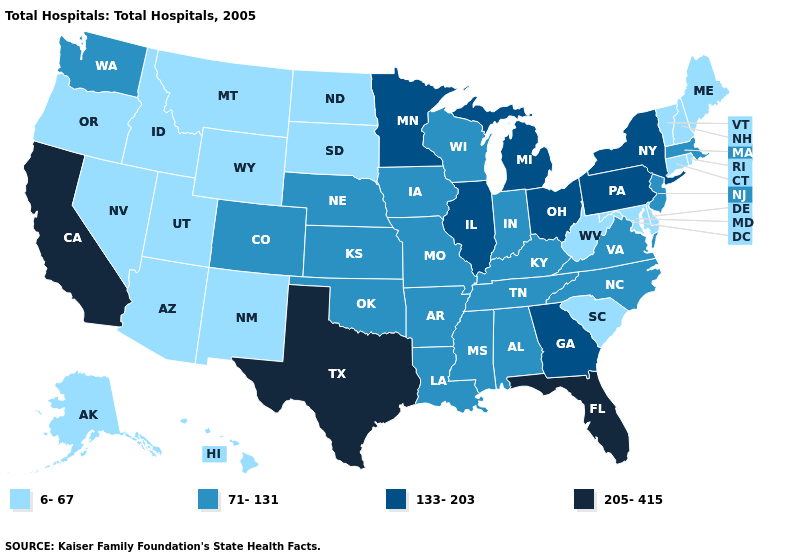Does Massachusetts have the lowest value in the USA?
Short answer required. No. Does Maryland have the lowest value in the USA?
Give a very brief answer. Yes. What is the lowest value in states that border Massachusetts?
Answer briefly. 6-67. Among the states that border Delaware , which have the highest value?
Give a very brief answer. Pennsylvania. Does Maryland have the same value as California?
Give a very brief answer. No. Name the states that have a value in the range 133-203?
Concise answer only. Georgia, Illinois, Michigan, Minnesota, New York, Ohio, Pennsylvania. What is the lowest value in the USA?
Quick response, please. 6-67. Name the states that have a value in the range 133-203?
Concise answer only. Georgia, Illinois, Michigan, Minnesota, New York, Ohio, Pennsylvania. Which states have the lowest value in the MidWest?
Keep it brief. North Dakota, South Dakota. Which states have the highest value in the USA?
Keep it brief. California, Florida, Texas. Does South Carolina have the lowest value in the USA?
Answer briefly. Yes. Name the states that have a value in the range 71-131?
Short answer required. Alabama, Arkansas, Colorado, Indiana, Iowa, Kansas, Kentucky, Louisiana, Massachusetts, Mississippi, Missouri, Nebraska, New Jersey, North Carolina, Oklahoma, Tennessee, Virginia, Washington, Wisconsin. Among the states that border Utah , does Colorado have the highest value?
Keep it brief. Yes. Among the states that border Florida , does Alabama have the lowest value?
Quick response, please. Yes. What is the value of Arkansas?
Short answer required. 71-131. 